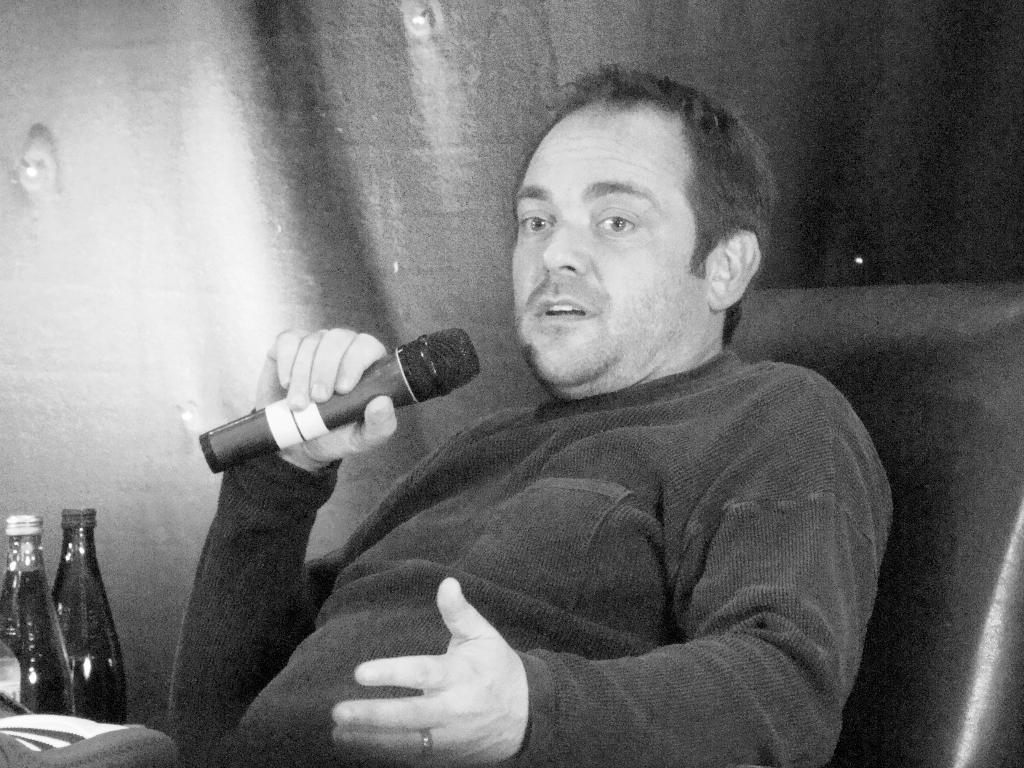Who is present in the image? There is a man in the image. What is the man doing in the image? The man is seated and talking. What object is the man holding in the image? The man is holding a microphone. What can be seen on the left side of the image? There are two bottles on the left side of the image. What type of stone is being used as a weapon in the image? There is no stone or weapon present in the image. How many bombs can be seen in the image? There are no bombs present in the image. 